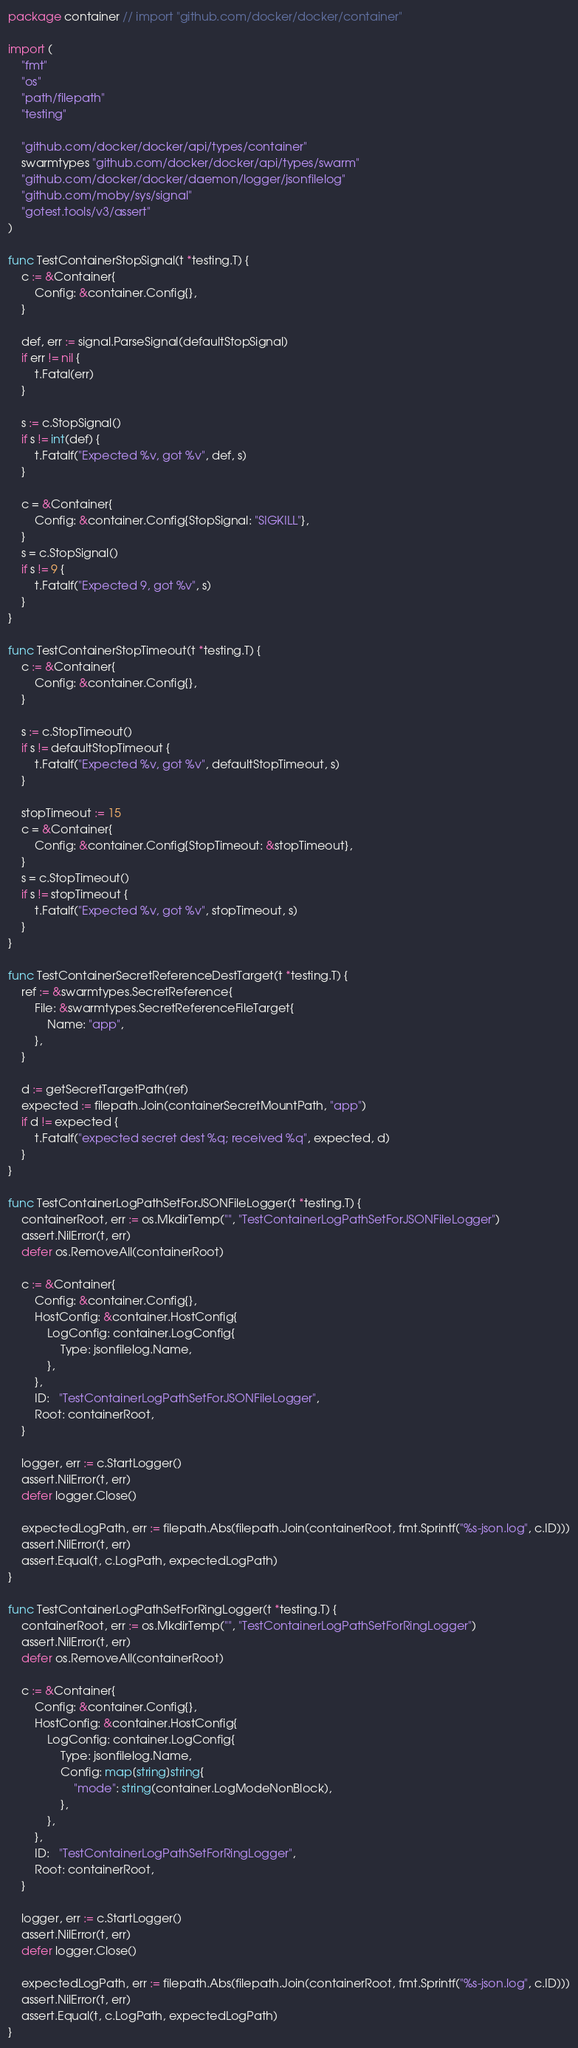Convert code to text. <code><loc_0><loc_0><loc_500><loc_500><_Go_>package container // import "github.com/docker/docker/container"

import (
	"fmt"
	"os"
	"path/filepath"
	"testing"

	"github.com/docker/docker/api/types/container"
	swarmtypes "github.com/docker/docker/api/types/swarm"
	"github.com/docker/docker/daemon/logger/jsonfilelog"
	"github.com/moby/sys/signal"
	"gotest.tools/v3/assert"
)

func TestContainerStopSignal(t *testing.T) {
	c := &Container{
		Config: &container.Config{},
	}

	def, err := signal.ParseSignal(defaultStopSignal)
	if err != nil {
		t.Fatal(err)
	}

	s := c.StopSignal()
	if s != int(def) {
		t.Fatalf("Expected %v, got %v", def, s)
	}

	c = &Container{
		Config: &container.Config{StopSignal: "SIGKILL"},
	}
	s = c.StopSignal()
	if s != 9 {
		t.Fatalf("Expected 9, got %v", s)
	}
}

func TestContainerStopTimeout(t *testing.T) {
	c := &Container{
		Config: &container.Config{},
	}

	s := c.StopTimeout()
	if s != defaultStopTimeout {
		t.Fatalf("Expected %v, got %v", defaultStopTimeout, s)
	}

	stopTimeout := 15
	c = &Container{
		Config: &container.Config{StopTimeout: &stopTimeout},
	}
	s = c.StopTimeout()
	if s != stopTimeout {
		t.Fatalf("Expected %v, got %v", stopTimeout, s)
	}
}

func TestContainerSecretReferenceDestTarget(t *testing.T) {
	ref := &swarmtypes.SecretReference{
		File: &swarmtypes.SecretReferenceFileTarget{
			Name: "app",
		},
	}

	d := getSecretTargetPath(ref)
	expected := filepath.Join(containerSecretMountPath, "app")
	if d != expected {
		t.Fatalf("expected secret dest %q; received %q", expected, d)
	}
}

func TestContainerLogPathSetForJSONFileLogger(t *testing.T) {
	containerRoot, err := os.MkdirTemp("", "TestContainerLogPathSetForJSONFileLogger")
	assert.NilError(t, err)
	defer os.RemoveAll(containerRoot)

	c := &Container{
		Config: &container.Config{},
		HostConfig: &container.HostConfig{
			LogConfig: container.LogConfig{
				Type: jsonfilelog.Name,
			},
		},
		ID:   "TestContainerLogPathSetForJSONFileLogger",
		Root: containerRoot,
	}

	logger, err := c.StartLogger()
	assert.NilError(t, err)
	defer logger.Close()

	expectedLogPath, err := filepath.Abs(filepath.Join(containerRoot, fmt.Sprintf("%s-json.log", c.ID)))
	assert.NilError(t, err)
	assert.Equal(t, c.LogPath, expectedLogPath)
}

func TestContainerLogPathSetForRingLogger(t *testing.T) {
	containerRoot, err := os.MkdirTemp("", "TestContainerLogPathSetForRingLogger")
	assert.NilError(t, err)
	defer os.RemoveAll(containerRoot)

	c := &Container{
		Config: &container.Config{},
		HostConfig: &container.HostConfig{
			LogConfig: container.LogConfig{
				Type: jsonfilelog.Name,
				Config: map[string]string{
					"mode": string(container.LogModeNonBlock),
				},
			},
		},
		ID:   "TestContainerLogPathSetForRingLogger",
		Root: containerRoot,
	}

	logger, err := c.StartLogger()
	assert.NilError(t, err)
	defer logger.Close()

	expectedLogPath, err := filepath.Abs(filepath.Join(containerRoot, fmt.Sprintf("%s-json.log", c.ID)))
	assert.NilError(t, err)
	assert.Equal(t, c.LogPath, expectedLogPath)
}
</code> 